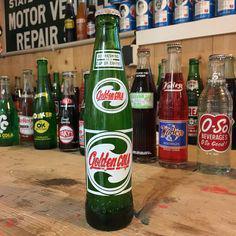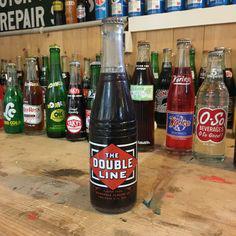The first image is the image on the left, the second image is the image on the right. Considering the images on both sides, is "Each bottle in front of the group is filled with a black liquid." valid? Answer yes or no. No. The first image is the image on the left, the second image is the image on the right. Examine the images to the left and right. Is the description "The left image features one green bottle of soda standing in front of rows of bottles, and the right image features one clear bottle of brown cola standing in front of rows of bottles." accurate? Answer yes or no. Yes. 